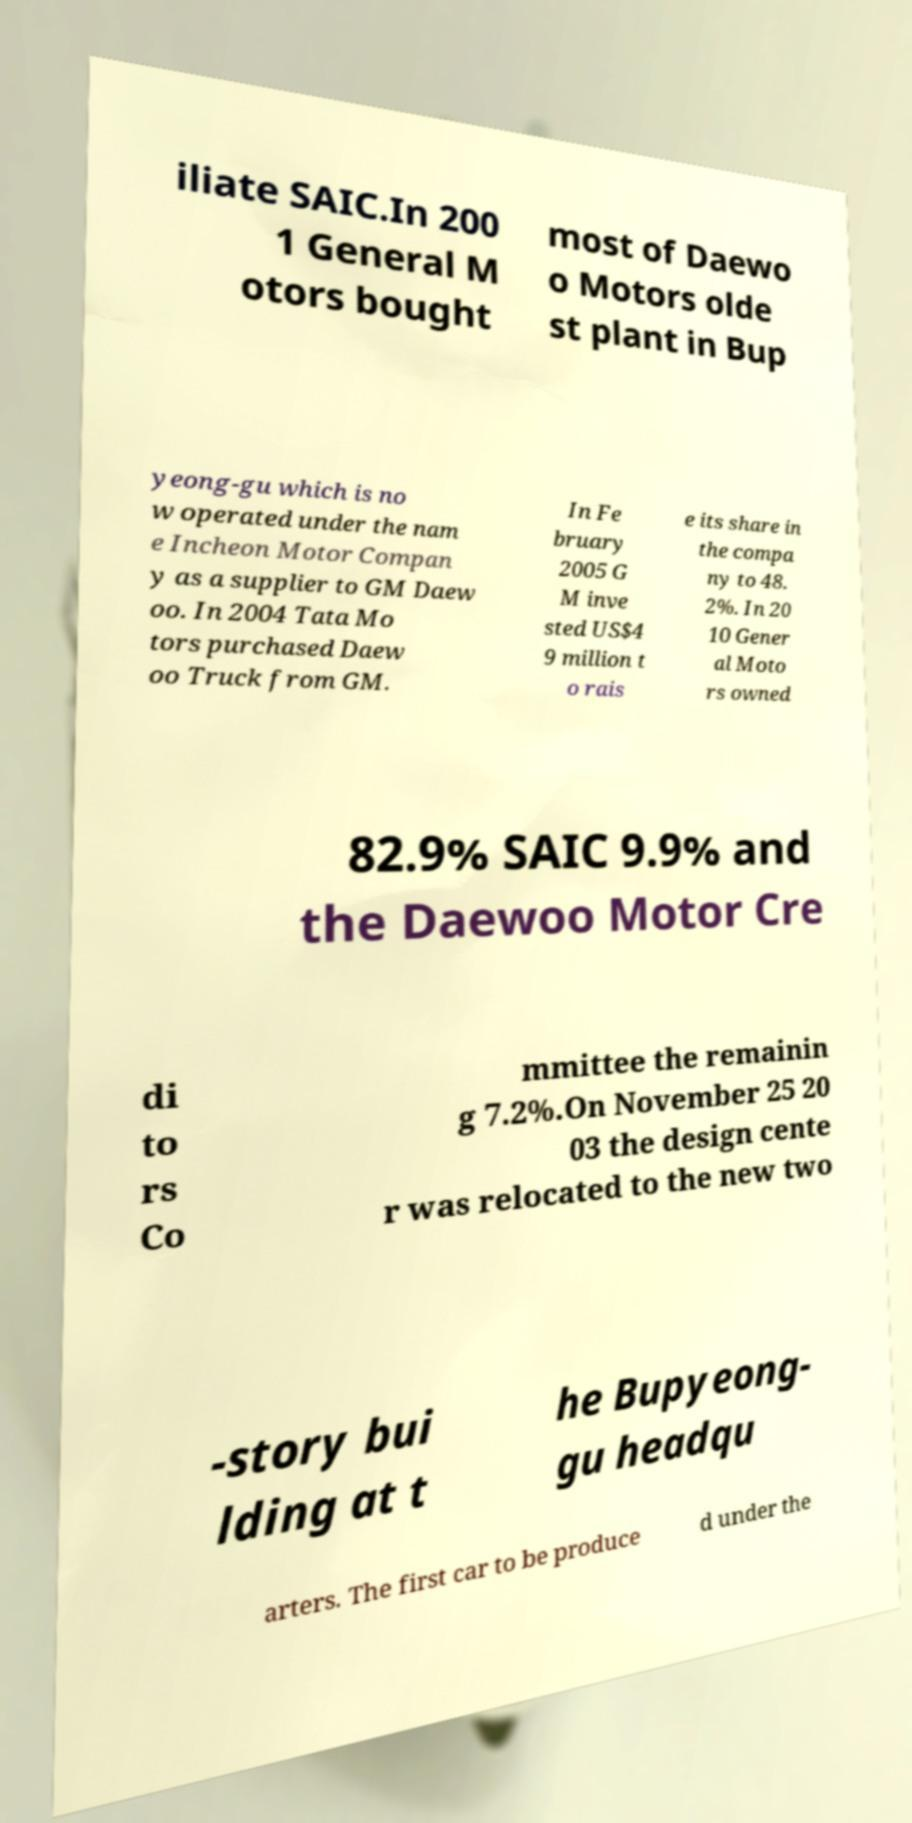Can you read and provide the text displayed in the image?This photo seems to have some interesting text. Can you extract and type it out for me? iliate SAIC.In 200 1 General M otors bought most of Daewo o Motors olde st plant in Bup yeong-gu which is no w operated under the nam e Incheon Motor Compan y as a supplier to GM Daew oo. In 2004 Tata Mo tors purchased Daew oo Truck from GM. In Fe bruary 2005 G M inve sted US$4 9 million t o rais e its share in the compa ny to 48. 2%. In 20 10 Gener al Moto rs owned 82.9% SAIC 9.9% and the Daewoo Motor Cre di to rs Co mmittee the remainin g 7.2%.On November 25 20 03 the design cente r was relocated to the new two -story bui lding at t he Bupyeong- gu headqu arters. The first car to be produce d under the 